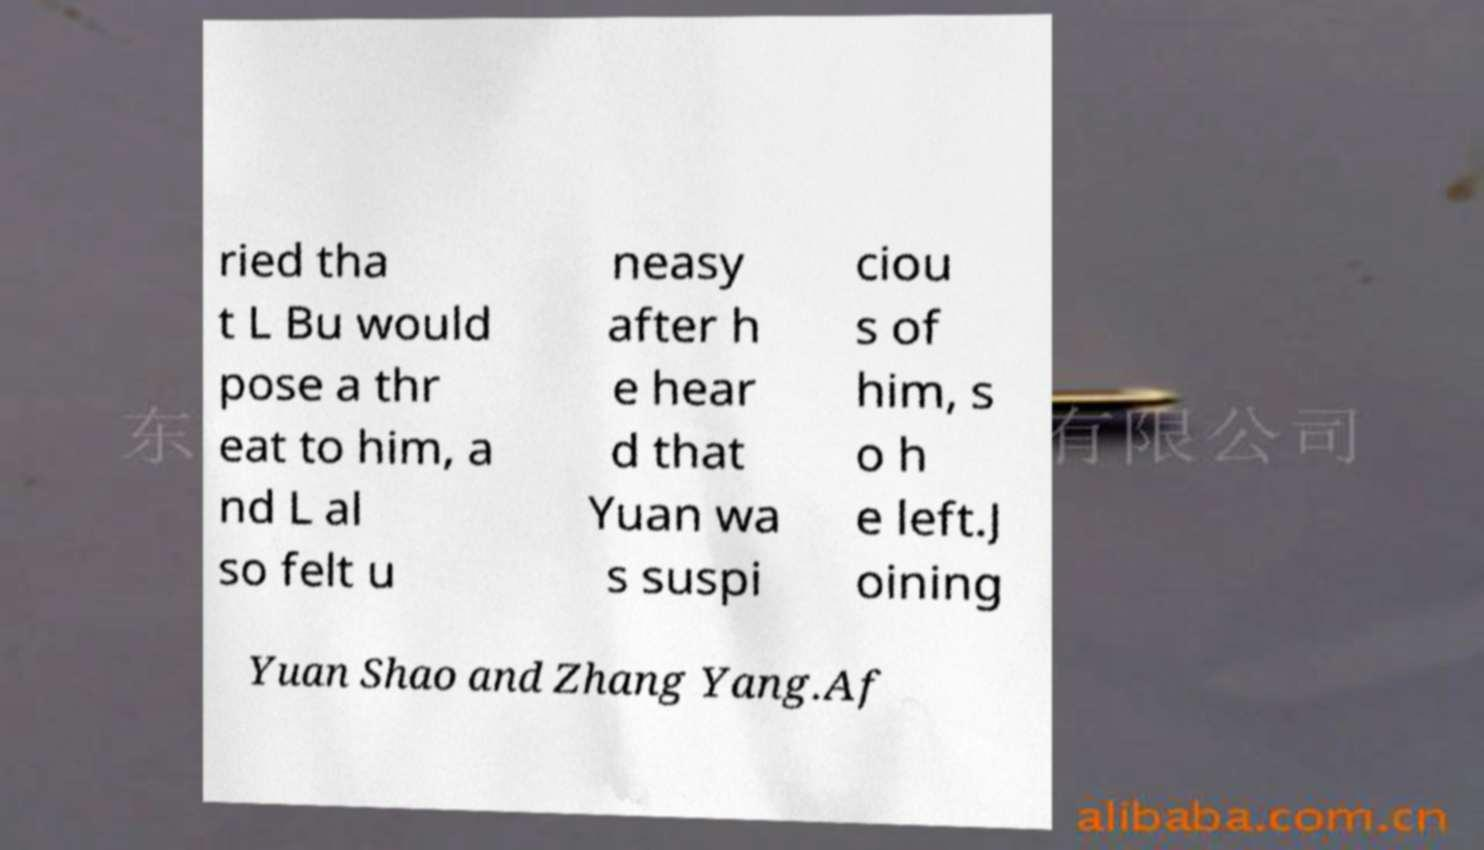Can you accurately transcribe the text from the provided image for me? ried tha t L Bu would pose a thr eat to him, a nd L al so felt u neasy after h e hear d that Yuan wa s suspi ciou s of him, s o h e left.J oining Yuan Shao and Zhang Yang.Af 